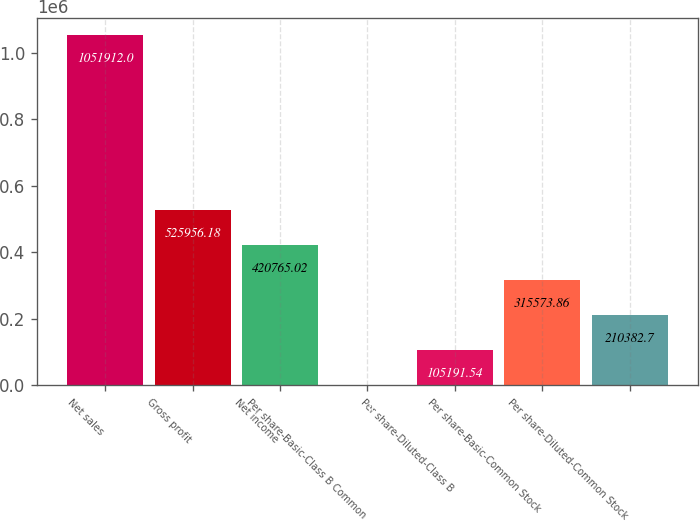Convert chart to OTSL. <chart><loc_0><loc_0><loc_500><loc_500><bar_chart><fcel>Net sales<fcel>Gross profit<fcel>Net income<fcel>Per share-Basic-Class B Common<fcel>Per share-Diluted-Class B<fcel>Per share-Basic-Common Stock<fcel>Per share-Diluted-Common Stock<nl><fcel>1.05191e+06<fcel>525956<fcel>420765<fcel>0.38<fcel>105192<fcel>315574<fcel>210383<nl></chart> 